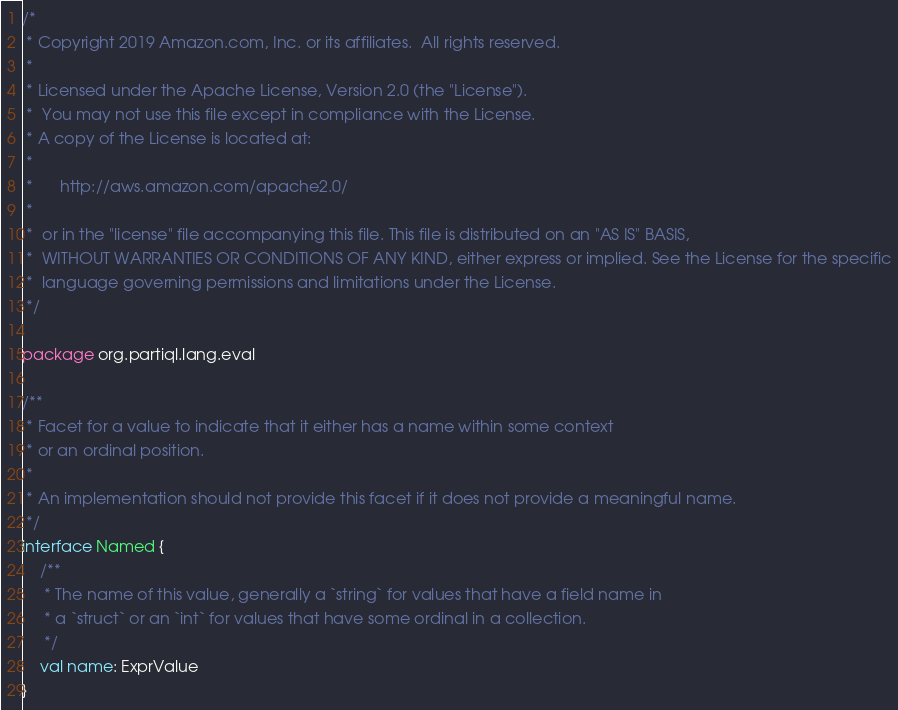Convert code to text. <code><loc_0><loc_0><loc_500><loc_500><_Kotlin_>/*
 * Copyright 2019 Amazon.com, Inc. or its affiliates.  All rights reserved.
 *
 * Licensed under the Apache License, Version 2.0 (the "License").
 *  You may not use this file except in compliance with the License.
 * A copy of the License is located at:
 *
 *      http://aws.amazon.com/apache2.0/
 *
 *  or in the "license" file accompanying this file. This file is distributed on an "AS IS" BASIS,
 *  WITHOUT WARRANTIES OR CONDITIONS OF ANY KIND, either express or implied. See the License for the specific
 *  language governing permissions and limitations under the License.
 */

package org.partiql.lang.eval

/**
 * Facet for a value to indicate that it either has a name within some context
 * or an ordinal position.
 *
 * An implementation should not provide this facet if it does not provide a meaningful name.
 */
interface Named {
    /**
     * The name of this value, generally a `string` for values that have a field name in
     * a `struct` or an `int` for values that have some ordinal in a collection.
     */
    val name: ExprValue
}
</code> 